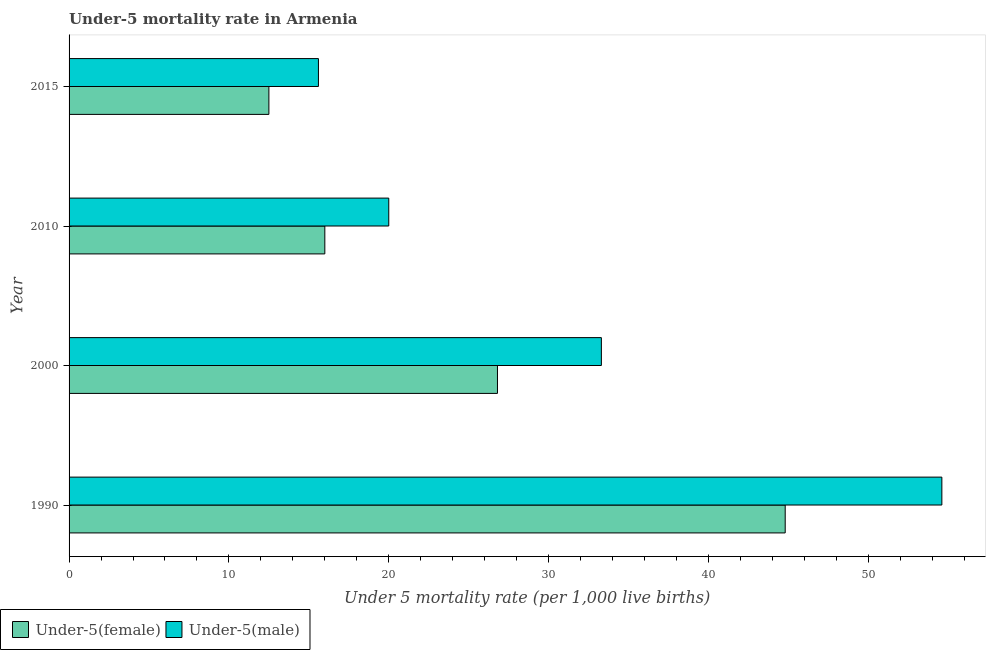How many different coloured bars are there?
Your response must be concise. 2. Are the number of bars per tick equal to the number of legend labels?
Provide a short and direct response. Yes. How many bars are there on the 4th tick from the top?
Your response must be concise. 2. How many bars are there on the 1st tick from the bottom?
Your response must be concise. 2. In how many cases, is the number of bars for a given year not equal to the number of legend labels?
Your response must be concise. 0. What is the under-5 female mortality rate in 2000?
Ensure brevity in your answer.  26.8. Across all years, what is the maximum under-5 male mortality rate?
Offer a terse response. 54.6. In which year was the under-5 female mortality rate minimum?
Your answer should be very brief. 2015. What is the total under-5 male mortality rate in the graph?
Offer a terse response. 123.5. What is the difference between the under-5 female mortality rate in 2000 and that in 2015?
Your response must be concise. 14.3. What is the difference between the under-5 female mortality rate in 1990 and the under-5 male mortality rate in 2010?
Your answer should be compact. 24.8. What is the average under-5 male mortality rate per year?
Provide a succinct answer. 30.88. In the year 2010, what is the difference between the under-5 male mortality rate and under-5 female mortality rate?
Your answer should be compact. 4. What is the ratio of the under-5 male mortality rate in 2000 to that in 2010?
Make the answer very short. 1.67. What is the difference between the highest and the lowest under-5 female mortality rate?
Offer a terse response. 32.3. Is the sum of the under-5 male mortality rate in 2000 and 2010 greater than the maximum under-5 female mortality rate across all years?
Offer a very short reply. Yes. What does the 1st bar from the top in 2000 represents?
Keep it short and to the point. Under-5(male). What does the 1st bar from the bottom in 2015 represents?
Your response must be concise. Under-5(female). How many years are there in the graph?
Offer a terse response. 4. Does the graph contain any zero values?
Make the answer very short. No. Does the graph contain grids?
Ensure brevity in your answer.  No. What is the title of the graph?
Your answer should be compact. Under-5 mortality rate in Armenia. What is the label or title of the X-axis?
Your response must be concise. Under 5 mortality rate (per 1,0 live births). What is the Under 5 mortality rate (per 1,000 live births) in Under-5(female) in 1990?
Provide a succinct answer. 44.8. What is the Under 5 mortality rate (per 1,000 live births) in Under-5(male) in 1990?
Provide a short and direct response. 54.6. What is the Under 5 mortality rate (per 1,000 live births) of Under-5(female) in 2000?
Provide a short and direct response. 26.8. What is the Under 5 mortality rate (per 1,000 live births) in Under-5(male) in 2000?
Offer a very short reply. 33.3. What is the Under 5 mortality rate (per 1,000 live births) of Under-5(male) in 2010?
Your answer should be compact. 20. What is the Under 5 mortality rate (per 1,000 live births) in Under-5(male) in 2015?
Your response must be concise. 15.6. Across all years, what is the maximum Under 5 mortality rate (per 1,000 live births) in Under-5(female)?
Offer a terse response. 44.8. Across all years, what is the maximum Under 5 mortality rate (per 1,000 live births) in Under-5(male)?
Your response must be concise. 54.6. Across all years, what is the minimum Under 5 mortality rate (per 1,000 live births) of Under-5(female)?
Provide a short and direct response. 12.5. Across all years, what is the minimum Under 5 mortality rate (per 1,000 live births) in Under-5(male)?
Your response must be concise. 15.6. What is the total Under 5 mortality rate (per 1,000 live births) of Under-5(female) in the graph?
Your answer should be very brief. 100.1. What is the total Under 5 mortality rate (per 1,000 live births) in Under-5(male) in the graph?
Offer a terse response. 123.5. What is the difference between the Under 5 mortality rate (per 1,000 live births) in Under-5(male) in 1990 and that in 2000?
Your answer should be compact. 21.3. What is the difference between the Under 5 mortality rate (per 1,000 live births) in Under-5(female) in 1990 and that in 2010?
Offer a very short reply. 28.8. What is the difference between the Under 5 mortality rate (per 1,000 live births) of Under-5(male) in 1990 and that in 2010?
Provide a succinct answer. 34.6. What is the difference between the Under 5 mortality rate (per 1,000 live births) in Under-5(female) in 1990 and that in 2015?
Ensure brevity in your answer.  32.3. What is the difference between the Under 5 mortality rate (per 1,000 live births) in Under-5(male) in 1990 and that in 2015?
Your answer should be compact. 39. What is the difference between the Under 5 mortality rate (per 1,000 live births) of Under-5(male) in 2000 and that in 2015?
Offer a very short reply. 17.7. What is the difference between the Under 5 mortality rate (per 1,000 live births) in Under-5(female) in 2010 and that in 2015?
Keep it short and to the point. 3.5. What is the difference between the Under 5 mortality rate (per 1,000 live births) in Under-5(female) in 1990 and the Under 5 mortality rate (per 1,000 live births) in Under-5(male) in 2010?
Your answer should be very brief. 24.8. What is the difference between the Under 5 mortality rate (per 1,000 live births) in Under-5(female) in 1990 and the Under 5 mortality rate (per 1,000 live births) in Under-5(male) in 2015?
Keep it short and to the point. 29.2. What is the difference between the Under 5 mortality rate (per 1,000 live births) of Under-5(female) in 2000 and the Under 5 mortality rate (per 1,000 live births) of Under-5(male) in 2010?
Give a very brief answer. 6.8. What is the difference between the Under 5 mortality rate (per 1,000 live births) of Under-5(female) in 2000 and the Under 5 mortality rate (per 1,000 live births) of Under-5(male) in 2015?
Give a very brief answer. 11.2. What is the difference between the Under 5 mortality rate (per 1,000 live births) in Under-5(female) in 2010 and the Under 5 mortality rate (per 1,000 live births) in Under-5(male) in 2015?
Provide a short and direct response. 0.4. What is the average Under 5 mortality rate (per 1,000 live births) in Under-5(female) per year?
Provide a succinct answer. 25.02. What is the average Under 5 mortality rate (per 1,000 live births) of Under-5(male) per year?
Keep it short and to the point. 30.88. In the year 1990, what is the difference between the Under 5 mortality rate (per 1,000 live births) of Under-5(female) and Under 5 mortality rate (per 1,000 live births) of Under-5(male)?
Ensure brevity in your answer.  -9.8. In the year 2010, what is the difference between the Under 5 mortality rate (per 1,000 live births) of Under-5(female) and Under 5 mortality rate (per 1,000 live births) of Under-5(male)?
Offer a terse response. -4. In the year 2015, what is the difference between the Under 5 mortality rate (per 1,000 live births) in Under-5(female) and Under 5 mortality rate (per 1,000 live births) in Under-5(male)?
Make the answer very short. -3.1. What is the ratio of the Under 5 mortality rate (per 1,000 live births) in Under-5(female) in 1990 to that in 2000?
Make the answer very short. 1.67. What is the ratio of the Under 5 mortality rate (per 1,000 live births) of Under-5(male) in 1990 to that in 2000?
Your answer should be very brief. 1.64. What is the ratio of the Under 5 mortality rate (per 1,000 live births) in Under-5(male) in 1990 to that in 2010?
Provide a short and direct response. 2.73. What is the ratio of the Under 5 mortality rate (per 1,000 live births) of Under-5(female) in 1990 to that in 2015?
Ensure brevity in your answer.  3.58. What is the ratio of the Under 5 mortality rate (per 1,000 live births) in Under-5(male) in 1990 to that in 2015?
Make the answer very short. 3.5. What is the ratio of the Under 5 mortality rate (per 1,000 live births) in Under-5(female) in 2000 to that in 2010?
Provide a succinct answer. 1.68. What is the ratio of the Under 5 mortality rate (per 1,000 live births) of Under-5(male) in 2000 to that in 2010?
Offer a very short reply. 1.67. What is the ratio of the Under 5 mortality rate (per 1,000 live births) of Under-5(female) in 2000 to that in 2015?
Ensure brevity in your answer.  2.14. What is the ratio of the Under 5 mortality rate (per 1,000 live births) of Under-5(male) in 2000 to that in 2015?
Ensure brevity in your answer.  2.13. What is the ratio of the Under 5 mortality rate (per 1,000 live births) of Under-5(female) in 2010 to that in 2015?
Your response must be concise. 1.28. What is the ratio of the Under 5 mortality rate (per 1,000 live births) in Under-5(male) in 2010 to that in 2015?
Ensure brevity in your answer.  1.28. What is the difference between the highest and the second highest Under 5 mortality rate (per 1,000 live births) of Under-5(female)?
Offer a very short reply. 18. What is the difference between the highest and the second highest Under 5 mortality rate (per 1,000 live births) of Under-5(male)?
Give a very brief answer. 21.3. What is the difference between the highest and the lowest Under 5 mortality rate (per 1,000 live births) of Under-5(female)?
Provide a short and direct response. 32.3. What is the difference between the highest and the lowest Under 5 mortality rate (per 1,000 live births) in Under-5(male)?
Your answer should be very brief. 39. 